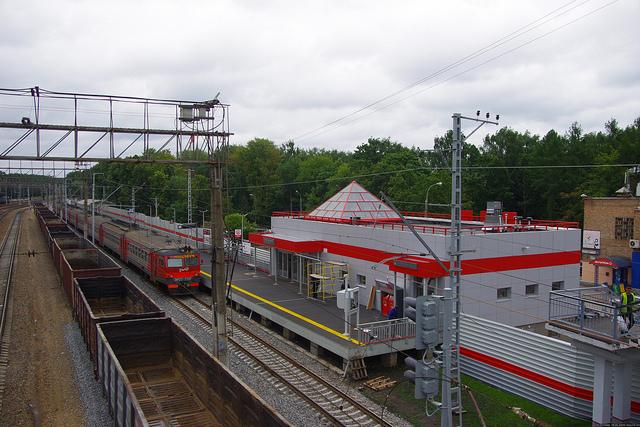How many train tracks are there?
Short answer required. 1. Is this the front of the train or the back?
Quick response, please. Front. Is the train moving?
Be succinct. Yes. What color is the building?
Give a very brief answer. Red and gray. Does the train's coloring match that of the station?
Keep it brief. Yes. Is the train traveling toward the station or away?
Short answer required. Toward. Does this train carry passengers?
Concise answer only. Yes. Is there an obstacle on the rails?
Give a very brief answer. No. 